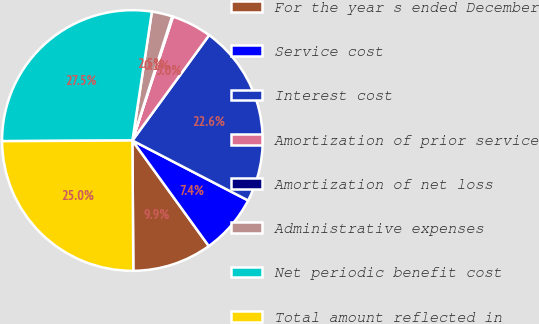Convert chart. <chart><loc_0><loc_0><loc_500><loc_500><pie_chart><fcel>For the year s ended December<fcel>Service cost<fcel>Interest cost<fcel>Amortization of prior service<fcel>Amortization of net loss<fcel>Administrative expenses<fcel>Net periodic benefit cost<fcel>Total amount reflected in<nl><fcel>9.86%<fcel>7.42%<fcel>22.59%<fcel>4.98%<fcel>0.11%<fcel>2.54%<fcel>27.47%<fcel>25.03%<nl></chart> 